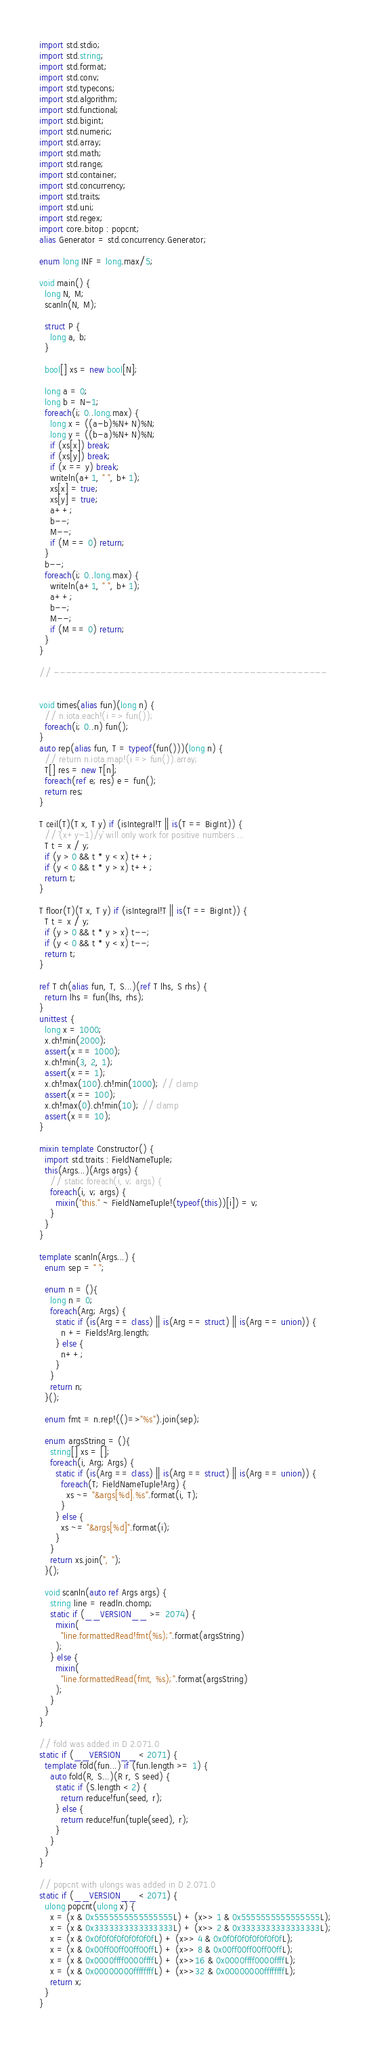<code> <loc_0><loc_0><loc_500><loc_500><_D_>import std.stdio;
import std.string;
import std.format;
import std.conv;
import std.typecons;
import std.algorithm;
import std.functional;
import std.bigint;
import std.numeric;
import std.array;
import std.math;
import std.range;
import std.container;
import std.concurrency;
import std.traits;
import std.uni;
import std.regex;
import core.bitop : popcnt;
alias Generator = std.concurrency.Generator;

enum long INF = long.max/5;

void main() {
  long N, M;
  scanln(N, M);

  struct P {
    long a, b;
  }

  bool[] xs = new bool[N];

  long a = 0;
  long b = N-1;
  foreach(i; 0..long.max) {
    long x = ((a-b)%N+N)%N;
    long y = ((b-a)%N+N)%N;
    if (xs[x]) break;
    if (xs[y]) break;
    if (x == y) break;
    writeln(a+1, " ", b+1);
    xs[x] = true;
    xs[y] = true;
    a++;
    b--;
    M--;
    if (M == 0) return;
  }
  b--;
  foreach(i; 0..long.max) {
    writeln(a+1, " ", b+1);
    a++;
    b--;
    M--;
    if (M == 0) return;
  }
}

// ----------------------------------------------


void times(alias fun)(long n) {
  // n.iota.each!(i => fun());
  foreach(i; 0..n) fun();
}
auto rep(alias fun, T = typeof(fun()))(long n) {
  // return n.iota.map!(i => fun()).array;
  T[] res = new T[n];
  foreach(ref e; res) e = fun();
  return res;
}

T ceil(T)(T x, T y) if (isIntegral!T || is(T == BigInt)) {
  // `(x+y-1)/y` will only work for positive numbers ...
  T t = x / y;
  if (y > 0 && t * y < x) t++;
  if (y < 0 && t * y > x) t++;
  return t;
}

T floor(T)(T x, T y) if (isIntegral!T || is(T == BigInt)) {
  T t = x / y;
  if (y > 0 && t * y > x) t--;
  if (y < 0 && t * y < x) t--;
  return t;
}

ref T ch(alias fun, T, S...)(ref T lhs, S rhs) {
  return lhs = fun(lhs, rhs);
}
unittest {
  long x = 1000;
  x.ch!min(2000);
  assert(x == 1000);
  x.ch!min(3, 2, 1);
  assert(x == 1);
  x.ch!max(100).ch!min(1000); // clamp
  assert(x == 100);
  x.ch!max(0).ch!min(10); // clamp
  assert(x == 10);
}

mixin template Constructor() {
  import std.traits : FieldNameTuple;
  this(Args...)(Args args) {
    // static foreach(i, v; args) {
    foreach(i, v; args) {
      mixin("this." ~ FieldNameTuple!(typeof(this))[i]) = v;
    }
  }
}

template scanln(Args...) {
  enum sep = " ";

  enum n = (){
    long n = 0;
    foreach(Arg; Args) {
      static if (is(Arg == class) || is(Arg == struct) || is(Arg == union)) {
        n += Fields!Arg.length;
      } else {
        n++;
      }
    }
    return n;
  }();

  enum fmt = n.rep!(()=>"%s").join(sep);

  enum argsString = (){
    string[] xs = [];
    foreach(i, Arg; Args) {
      static if (is(Arg == class) || is(Arg == struct) || is(Arg == union)) {
        foreach(T; FieldNameTuple!Arg) {
          xs ~= "&args[%d].%s".format(i, T);
        }
      } else {
        xs ~= "&args[%d]".format(i);
      }
    }
    return xs.join(", ");
  }();

  void scanln(auto ref Args args) {
    string line = readln.chomp;
    static if (__VERSION__ >= 2074) {
      mixin(
        "line.formattedRead!fmt(%s);".format(argsString)
      );
    } else {
      mixin(
        "line.formattedRead(fmt, %s);".format(argsString)
      );
    }
  }
}

// fold was added in D 2.071.0
static if (__VERSION__ < 2071) {
  template fold(fun...) if (fun.length >= 1) {
    auto fold(R, S...)(R r, S seed) {
      static if (S.length < 2) {
        return reduce!fun(seed, r);
      } else {
        return reduce!fun(tuple(seed), r);
      }
    }
  }
}

// popcnt with ulongs was added in D 2.071.0
static if (__VERSION__ < 2071) {
  ulong popcnt(ulong x) {
    x = (x & 0x5555555555555555L) + (x>> 1 & 0x5555555555555555L);
    x = (x & 0x3333333333333333L) + (x>> 2 & 0x3333333333333333L);
    x = (x & 0x0f0f0f0f0f0f0f0fL) + (x>> 4 & 0x0f0f0f0f0f0f0f0fL);
    x = (x & 0x00ff00ff00ff00ffL) + (x>> 8 & 0x00ff00ff00ff00ffL);
    x = (x & 0x0000ffff0000ffffL) + (x>>16 & 0x0000ffff0000ffffL);
    x = (x & 0x00000000ffffffffL) + (x>>32 & 0x00000000ffffffffL);
    return x;
  }
}
</code> 